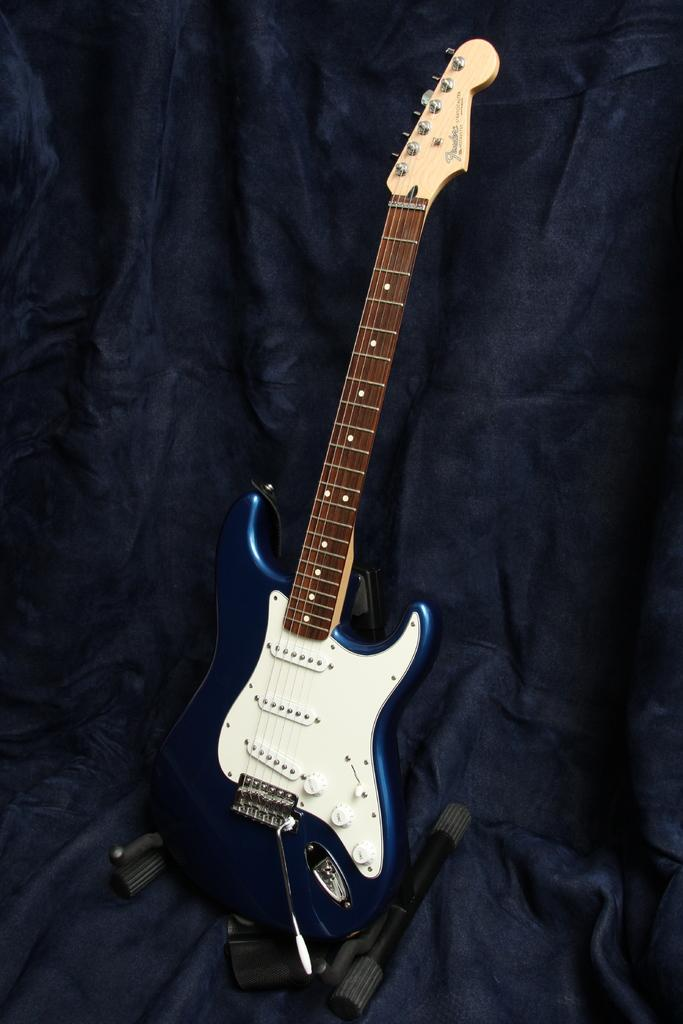What musical instrument is in the image? There is a guitar in the image. Where is the guitar located? The guitar is on a chair. What else can be seen near the guitar? There are objects beside the guitar. How many lizards are crawling on the guitar in the image? There are no lizards present in the image; the guitar is on a chair with objects beside it. 